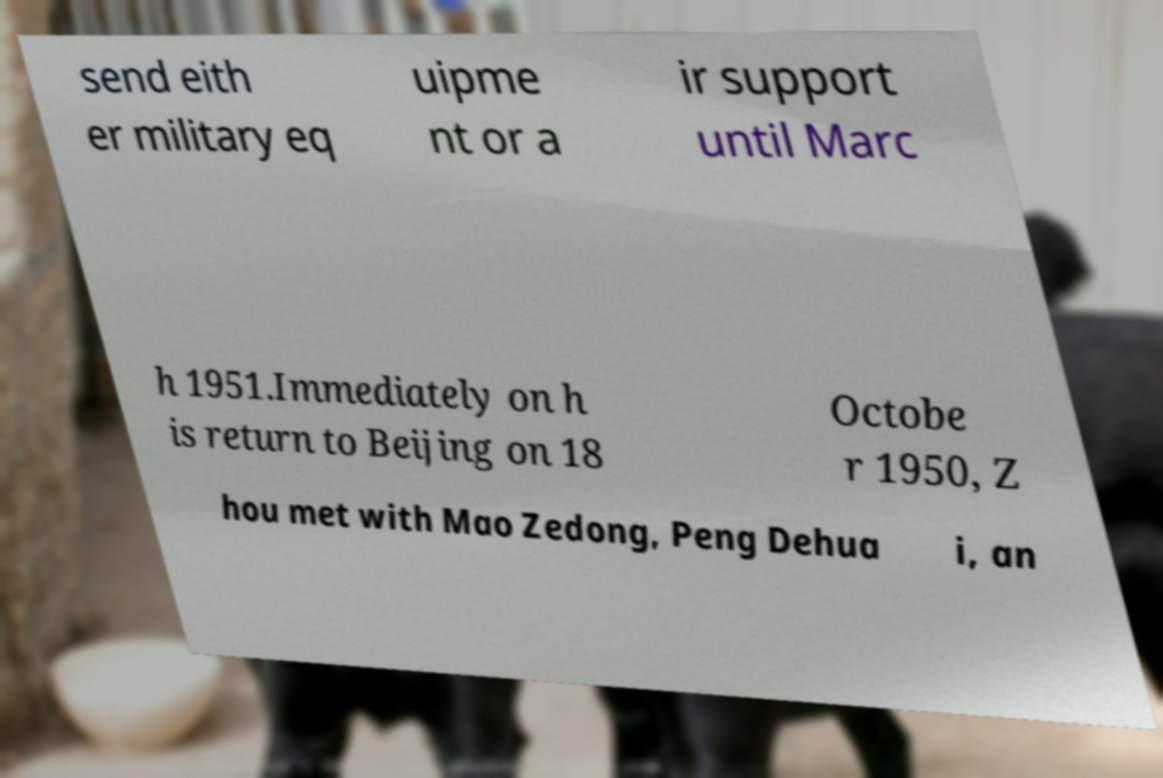There's text embedded in this image that I need extracted. Can you transcribe it verbatim? send eith er military eq uipme nt or a ir support until Marc h 1951.Immediately on h is return to Beijing on 18 Octobe r 1950, Z hou met with Mao Zedong, Peng Dehua i, an 